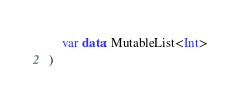<code> <loc_0><loc_0><loc_500><loc_500><_Kotlin_>	var data: MutableList<Int>
)
</code> 